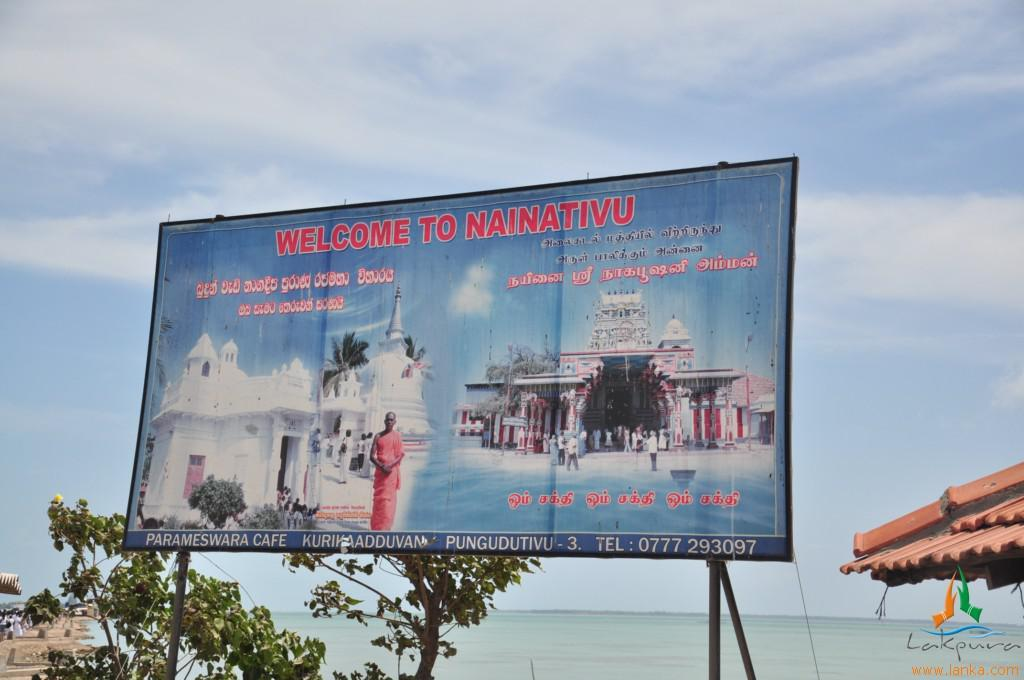Provide a one-sentence caption for the provided image. welcome to naintivu street huge banner next to the beach. 